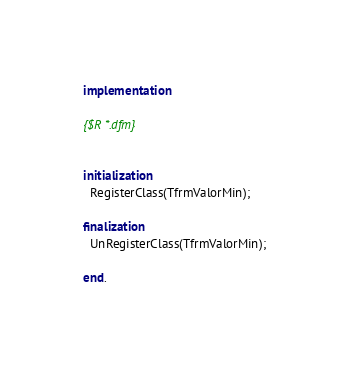Convert code to text. <code><loc_0><loc_0><loc_500><loc_500><_Pascal_>implementation

{$R *.dfm}


initialization
  RegisterClass(TfrmValorMin);

finalization
  UnRegisterClass(TfrmValorMin);

end.
</code> 